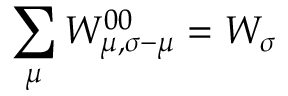Convert formula to latex. <formula><loc_0><loc_0><loc_500><loc_500>\sum _ { \mu } W _ { \mu , \sigma - \mu } ^ { 0 0 } = W _ { \sigma }</formula> 